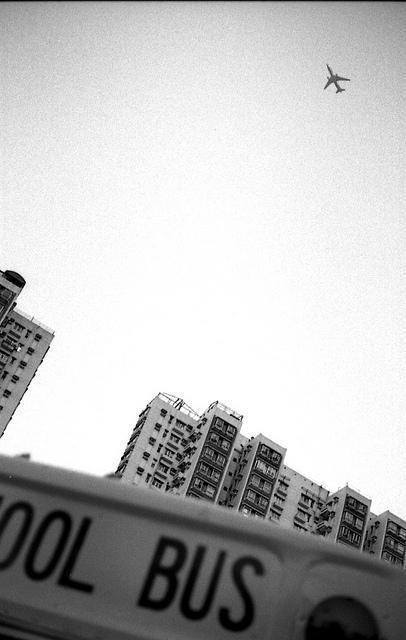Evaluate: Does the caption "The bus is far away from the airplane." match the image?
Answer yes or no. Yes. Does the caption "The airplane is far away from the bus." correctly depict the image?
Answer yes or no. Yes. 